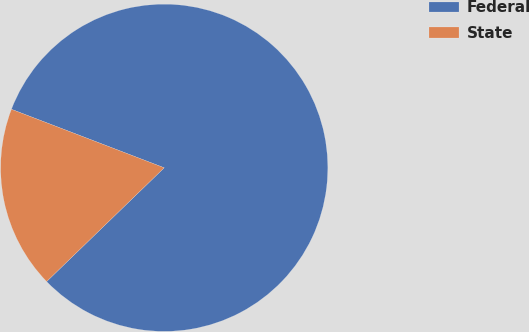<chart> <loc_0><loc_0><loc_500><loc_500><pie_chart><fcel>Federal<fcel>State<nl><fcel>81.94%<fcel>18.06%<nl></chart> 